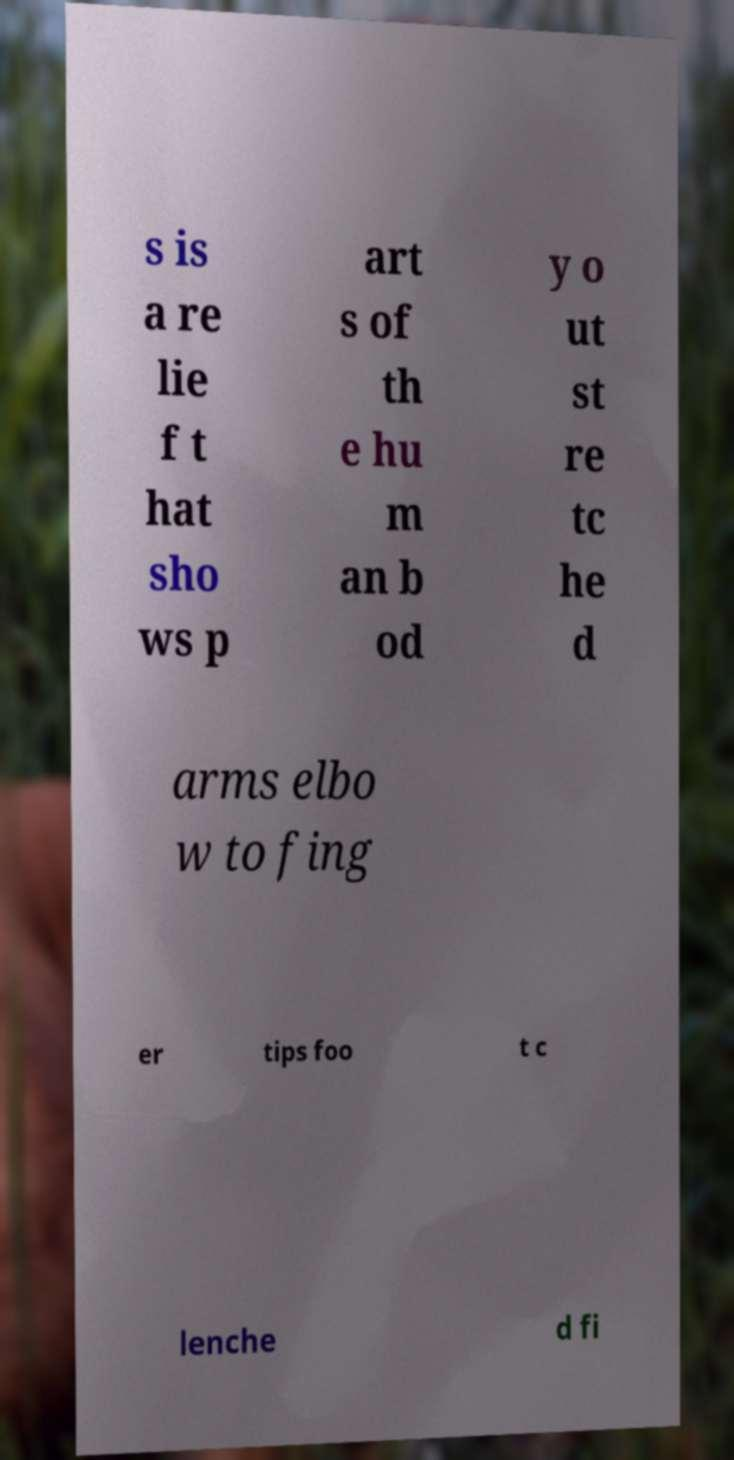Please read and relay the text visible in this image. What does it say? s is a re lie f t hat sho ws p art s of th e hu m an b od y o ut st re tc he d arms elbo w to fing er tips foo t c lenche d fi 